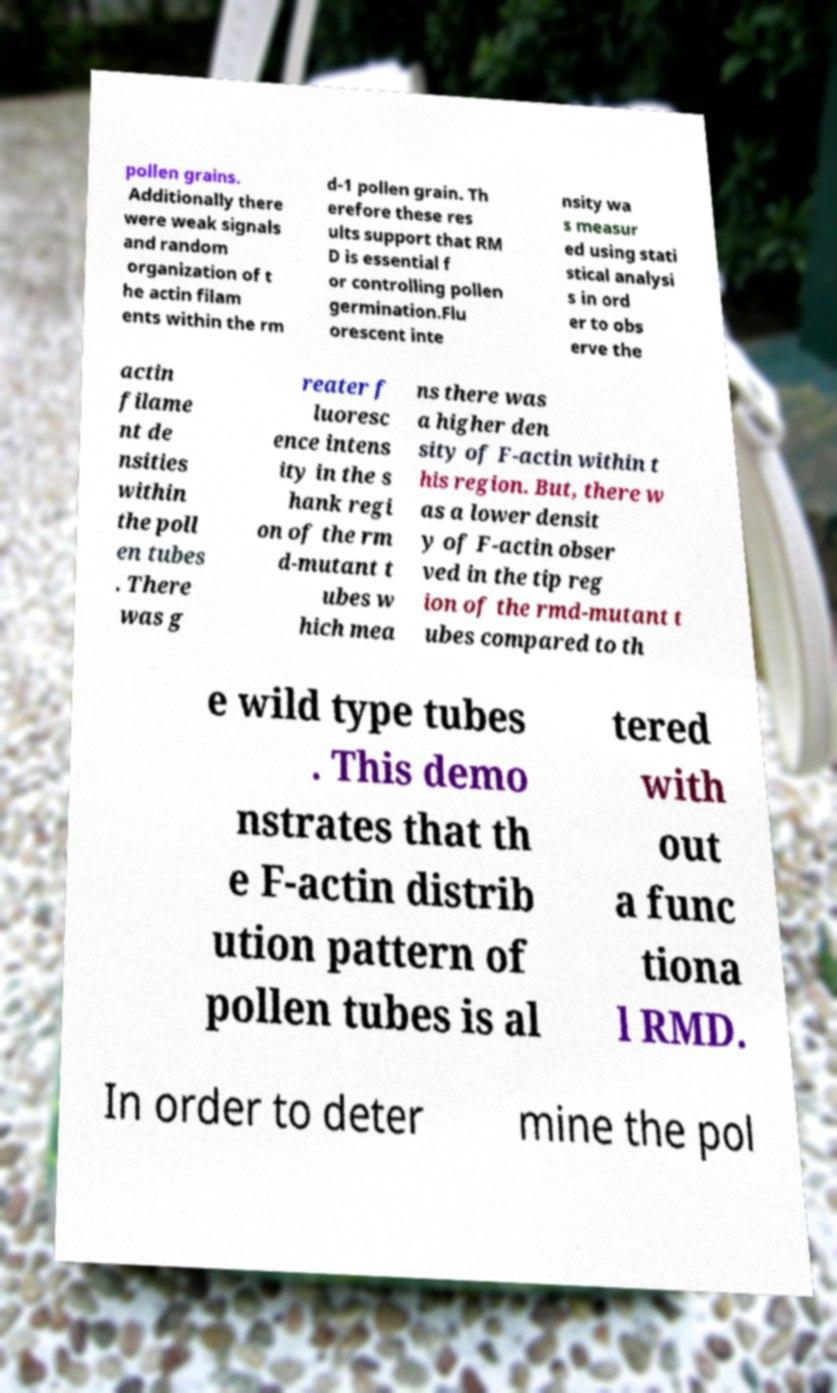There's text embedded in this image that I need extracted. Can you transcribe it verbatim? pollen grains. Additionally there were weak signals and random organization of t he actin filam ents within the rm d-1 pollen grain. Th erefore these res ults support that RM D is essential f or controlling pollen germination.Flu orescent inte nsity wa s measur ed using stati stical analysi s in ord er to obs erve the actin filame nt de nsities within the poll en tubes . There was g reater f luoresc ence intens ity in the s hank regi on of the rm d-mutant t ubes w hich mea ns there was a higher den sity of F-actin within t his region. But, there w as a lower densit y of F-actin obser ved in the tip reg ion of the rmd-mutant t ubes compared to th e wild type tubes . This demo nstrates that th e F-actin distrib ution pattern of pollen tubes is al tered with out a func tiona l RMD. In order to deter mine the pol 